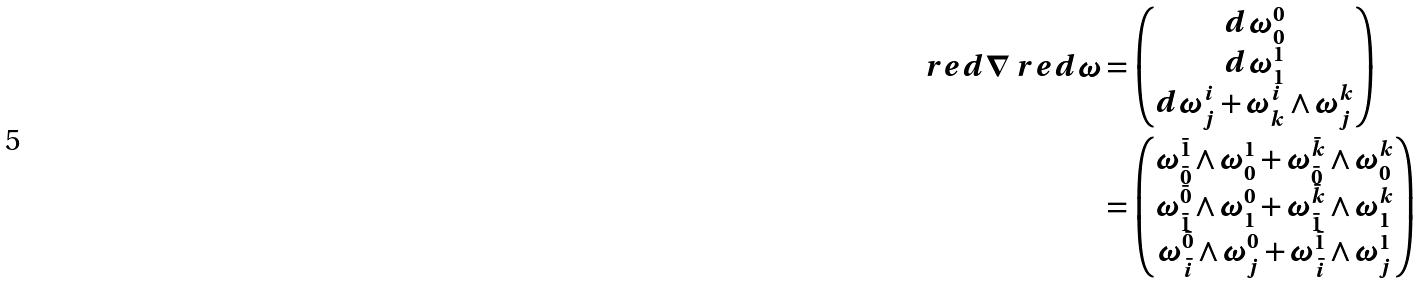Convert formula to latex. <formula><loc_0><loc_0><loc_500><loc_500>\ r e d { \nabla } \ r e d { \omega } & = \begin{pmatrix} d \omega ^ { 0 } _ { 0 } \\ d \omega ^ { 1 } _ { 1 } \\ d \omega ^ { i } _ { j } + \omega ^ { i } _ { k } \wedge \omega ^ { k } _ { j } \\ \end{pmatrix} \\ & = \begin{pmatrix} \omega ^ { \bar { 1 } } _ { \bar { 0 } } \wedge \omega ^ { 1 } _ { 0 } + \omega ^ { \bar { k } } _ { \bar { 0 } } \wedge \omega ^ { k } _ { 0 } \\ \omega ^ { \bar { 0 } } _ { \bar { 1 } } \wedge \omega ^ { 0 } _ { 1 } + \omega ^ { \bar { k } } _ { \bar { 1 } } \wedge \omega ^ { k } _ { 1 } \\ \omega ^ { \bar { 0 } } _ { \bar { i } } \wedge \omega ^ { 0 } _ { j } + \omega ^ { \bar { 1 } } _ { \bar { i } } \wedge \omega ^ { 1 } _ { j } \end{pmatrix}</formula> 